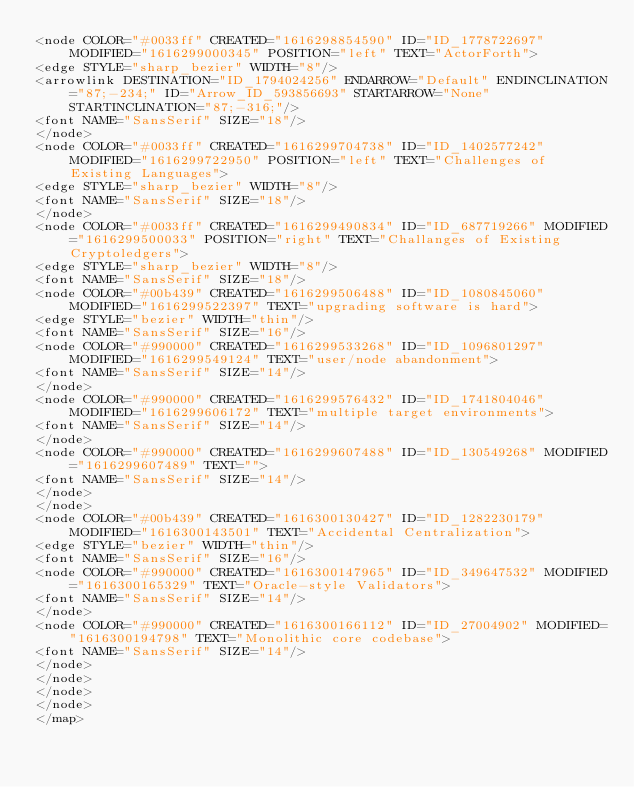Convert code to text. <code><loc_0><loc_0><loc_500><loc_500><_ObjectiveC_><node COLOR="#0033ff" CREATED="1616298854590" ID="ID_1778722697" MODIFIED="1616299000345" POSITION="left" TEXT="ActorForth">
<edge STYLE="sharp_bezier" WIDTH="8"/>
<arrowlink DESTINATION="ID_1794024256" ENDARROW="Default" ENDINCLINATION="87;-234;" ID="Arrow_ID_593856693" STARTARROW="None" STARTINCLINATION="87;-316;"/>
<font NAME="SansSerif" SIZE="18"/>
</node>
<node COLOR="#0033ff" CREATED="1616299704738" ID="ID_1402577242" MODIFIED="1616299722950" POSITION="left" TEXT="Challenges of Existing Languages">
<edge STYLE="sharp_bezier" WIDTH="8"/>
<font NAME="SansSerif" SIZE="18"/>
</node>
<node COLOR="#0033ff" CREATED="1616299490834" ID="ID_687719266" MODIFIED="1616299500033" POSITION="right" TEXT="Challanges of Existing Cryptoledgers">
<edge STYLE="sharp_bezier" WIDTH="8"/>
<font NAME="SansSerif" SIZE="18"/>
<node COLOR="#00b439" CREATED="1616299506488" ID="ID_1080845060" MODIFIED="1616299522397" TEXT="upgrading software is hard">
<edge STYLE="bezier" WIDTH="thin"/>
<font NAME="SansSerif" SIZE="16"/>
<node COLOR="#990000" CREATED="1616299533268" ID="ID_1096801297" MODIFIED="1616299549124" TEXT="user/node abandonment">
<font NAME="SansSerif" SIZE="14"/>
</node>
<node COLOR="#990000" CREATED="1616299576432" ID="ID_1741804046" MODIFIED="1616299606172" TEXT="multiple target environments">
<font NAME="SansSerif" SIZE="14"/>
</node>
<node COLOR="#990000" CREATED="1616299607488" ID="ID_130549268" MODIFIED="1616299607489" TEXT="">
<font NAME="SansSerif" SIZE="14"/>
</node>
</node>
<node COLOR="#00b439" CREATED="1616300130427" ID="ID_1282230179" MODIFIED="1616300143501" TEXT="Accidental Centralization">
<edge STYLE="bezier" WIDTH="thin"/>
<font NAME="SansSerif" SIZE="16"/>
<node COLOR="#990000" CREATED="1616300147965" ID="ID_349647532" MODIFIED="1616300165329" TEXT="Oracle-style Validators">
<font NAME="SansSerif" SIZE="14"/>
</node>
<node COLOR="#990000" CREATED="1616300166112" ID="ID_27004902" MODIFIED="1616300194798" TEXT="Monolithic core codebase">
<font NAME="SansSerif" SIZE="14"/>
</node>
</node>
</node>
</node>
</map>
</code> 